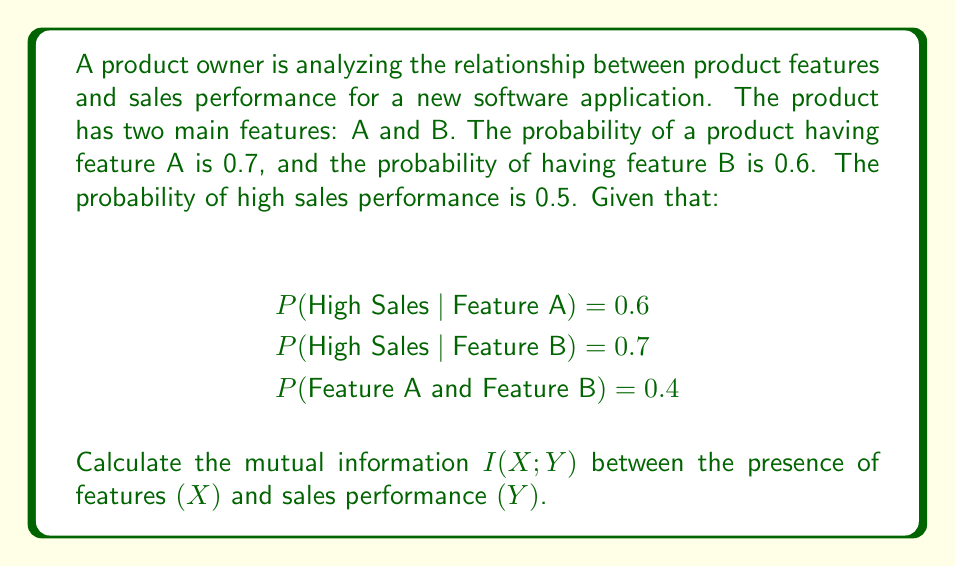Help me with this question. To calculate the mutual information I(X; Y), we need to follow these steps:

1. Define the random variables:
   X: Presence of features (A, B, Both, or None)
   Y: Sales performance (High or Low)

2. Calculate the joint probability distribution P(X, Y):

   P(A) = 0.7, P(B) = 0.6, P(A and B) = 0.4
   P(None) = 1 - P(A) - P(B) + P(A and B) = 1 - 0.7 - 0.6 + 0.4 = 0.1
   
   P(High Sales) = 0.5
   P(Low Sales) = 1 - 0.5 = 0.5

   P(High Sales | A) = 0.6
   P(High Sales | B) = 0.7
   P(High Sales | A and B) = 1 - (1 - 0.6) * (1 - 0.7) = 0.88 (assuming independence)
   P(High Sales | None) = (0.5 - 0.7 * 0.6 - 0.6 * 0.7 + 0.4 * 0.88) / 0.1 = 0.02

3. Calculate the marginal distributions P(X) and P(Y):

   P(X = A only) = 0.7 - 0.4 = 0.3
   P(X = B only) = 0.6 - 0.4 = 0.2
   P(X = Both) = 0.4
   P(X = None) = 0.1

   P(Y = High) = 0.5
   P(Y = Low) = 0.5

4. Calculate the joint distribution P(X, Y):

   P(X = A only, Y = High) = 0.3 * 0.6 = 0.18
   P(X = B only, Y = High) = 0.2 * 0.7 = 0.14
   P(X = Both, Y = High) = 0.4 * 0.88 = 0.352
   P(X = None, Y = High) = 0.1 * 0.02 = 0.002

5. Calculate the mutual information using the formula:

   $$I(X; Y) = \sum_{x \in X} \sum_{y \in Y} P(x, y) \log_2 \frac{P(x, y)}{P(x)P(y)}$$

   I(X; Y) = 0.18 * log2(0.18 / (0.3 * 0.5)) +
             0.14 * log2(0.14 / (0.2 * 0.5)) +
             0.352 * log2(0.352 / (0.4 * 0.5)) +
             0.002 * log2(0.002 / (0.1 * 0.5)) +
             0.12 * log2(0.12 / (0.3 * 0.5)) +
             0.06 * log2(0.06 / (0.2 * 0.5)) +
             0.048 * log2(0.048 / (0.4 * 0.5)) +
             0.098 * log2(0.098 / (0.1 * 0.5))

6. Compute the final result:

   I(X; Y) ≈ 0.3219 bits
Answer: The mutual information I(X; Y) between the presence of features and sales performance is approximately 0.3219 bits. 